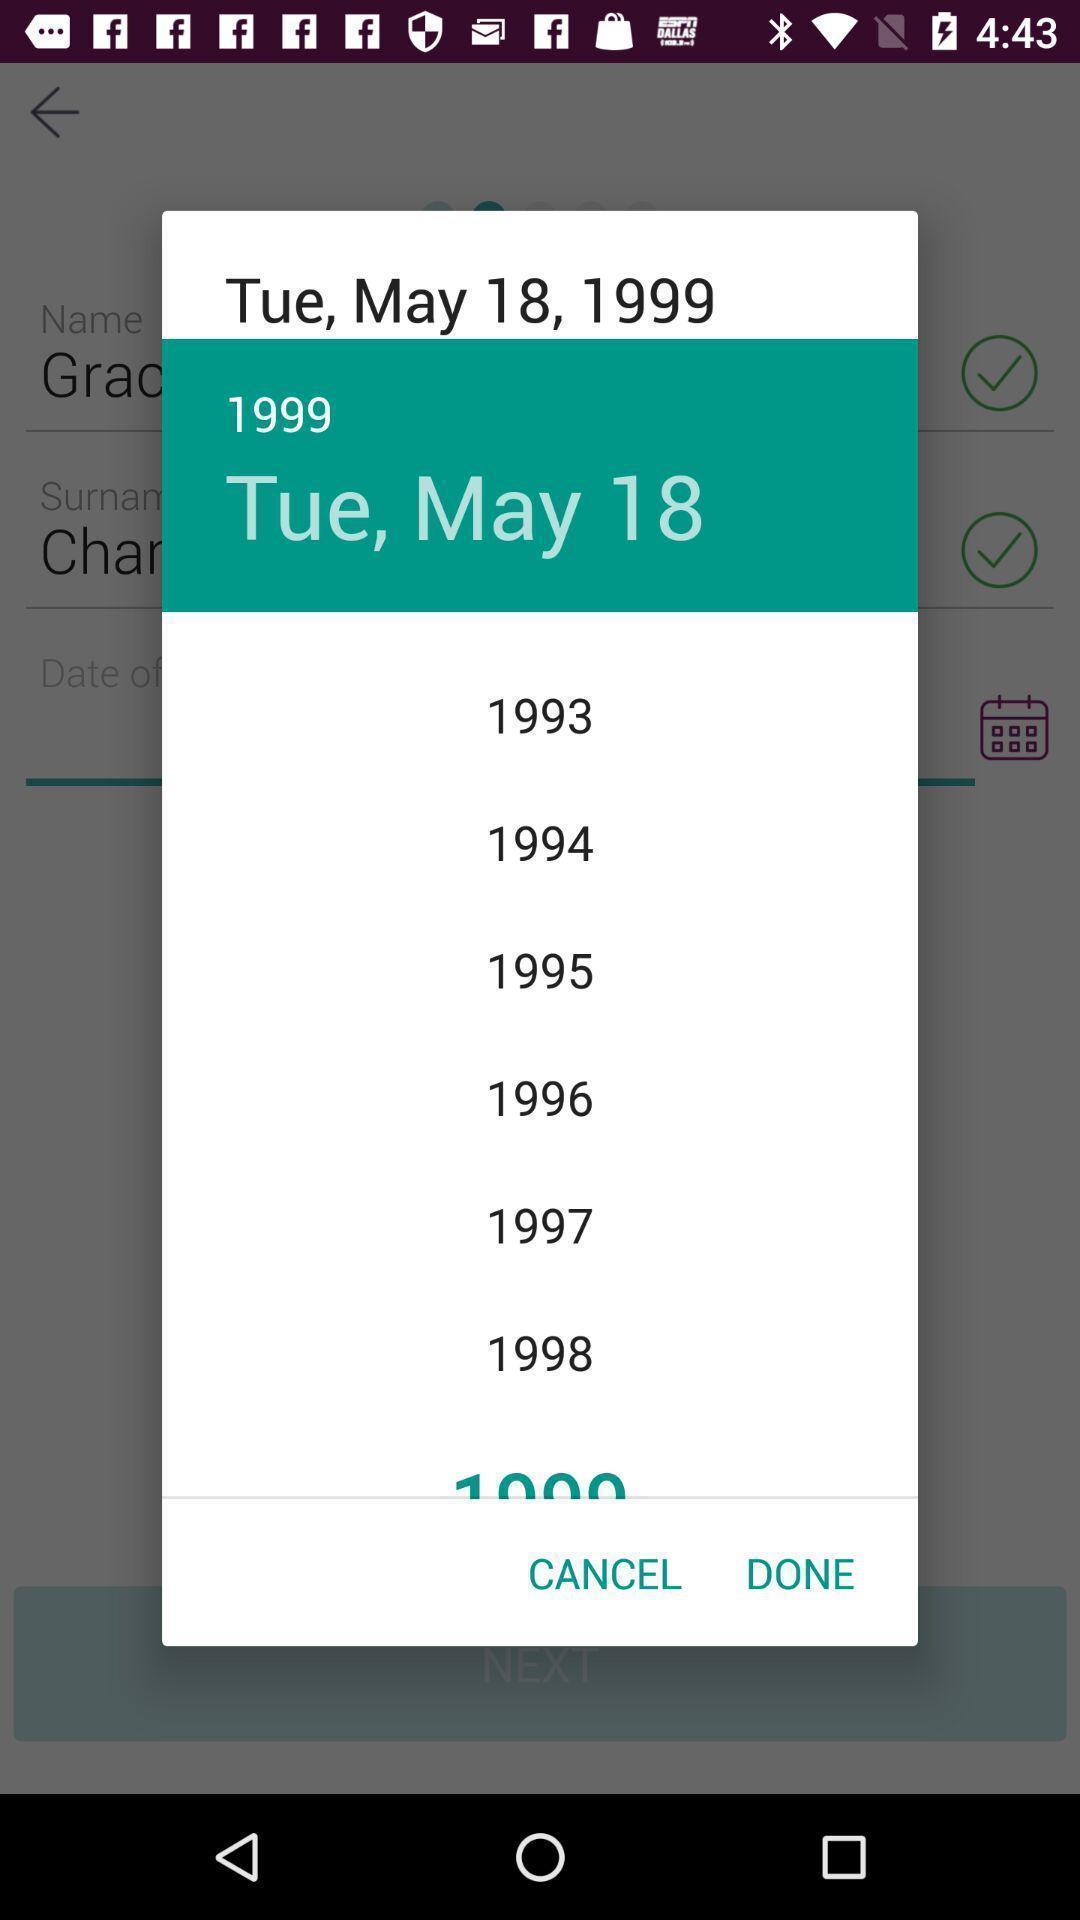Tell me what you see in this picture. Pop up showing year list in a financial app. 